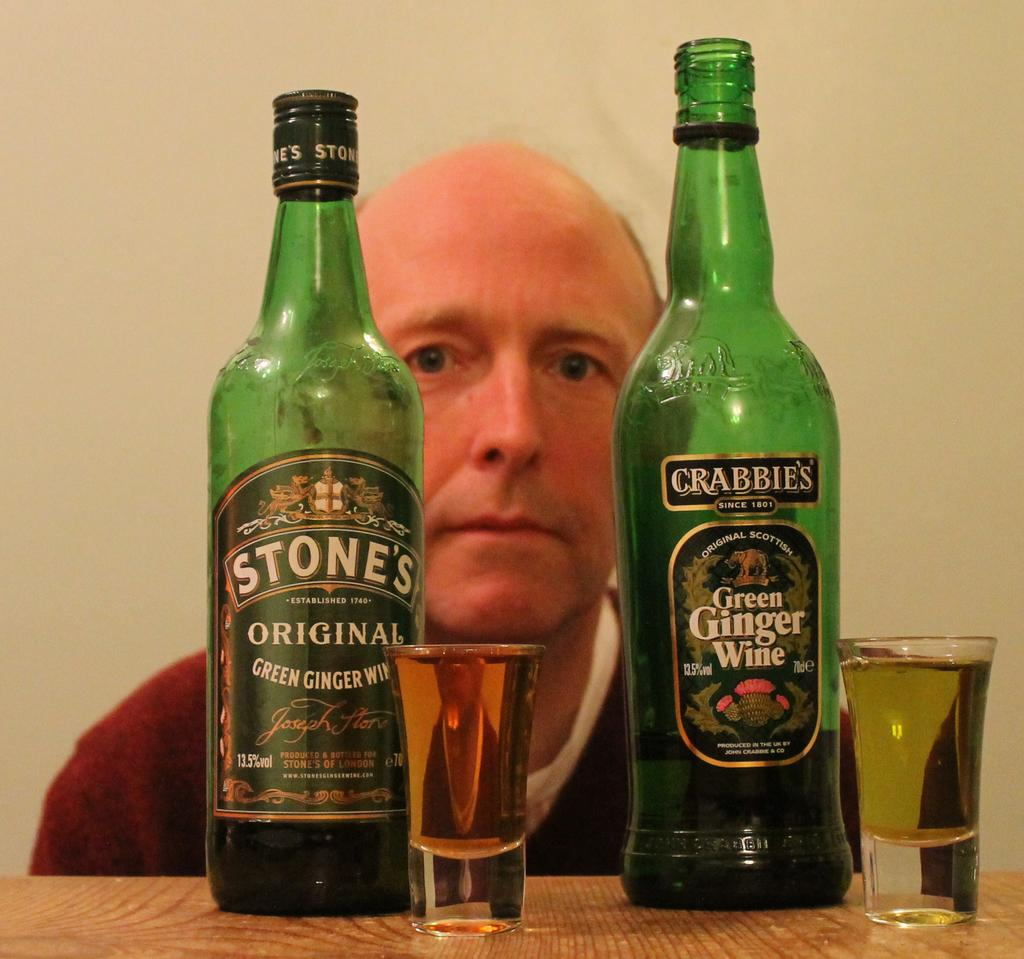What objects are present in the image that are related to wine? There are two wine bottles in the image, and they are green in color. What other items are visible in the image that might be used for drinking wine? There are two glasses in the image. Where are the glasses placed in the image? The glasses are placed on a table. Can you describe the person in the image? There is a man behind the table in the image. What type of cap is the man wearing in the image? There is no cap visible in the image. 